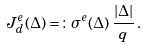<formula> <loc_0><loc_0><loc_500><loc_500>J ^ { e } _ { d } ( \Delta ) = \colon \sigma ^ { e } ( \Delta ) \, \frac { | \Delta | } { q } \, .</formula> 